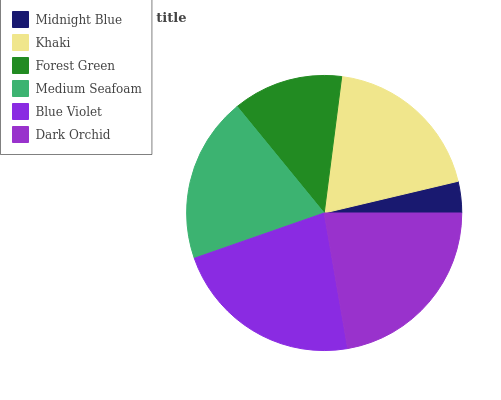Is Midnight Blue the minimum?
Answer yes or no. Yes. Is Blue Violet the maximum?
Answer yes or no. Yes. Is Khaki the minimum?
Answer yes or no. No. Is Khaki the maximum?
Answer yes or no. No. Is Khaki greater than Midnight Blue?
Answer yes or no. Yes. Is Midnight Blue less than Khaki?
Answer yes or no. Yes. Is Midnight Blue greater than Khaki?
Answer yes or no. No. Is Khaki less than Midnight Blue?
Answer yes or no. No. Is Medium Seafoam the high median?
Answer yes or no. Yes. Is Khaki the low median?
Answer yes or no. Yes. Is Blue Violet the high median?
Answer yes or no. No. Is Dark Orchid the low median?
Answer yes or no. No. 